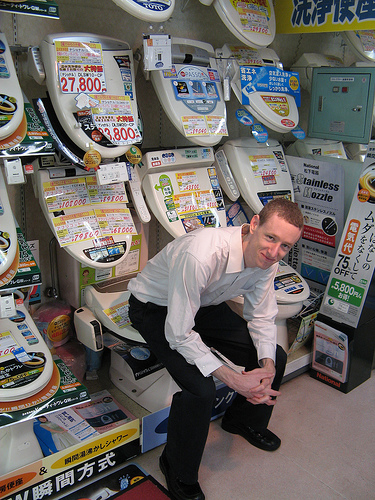How many toilets are visible in this store display? There are eight toilets visible in the display, each model offering unique features and designs. 